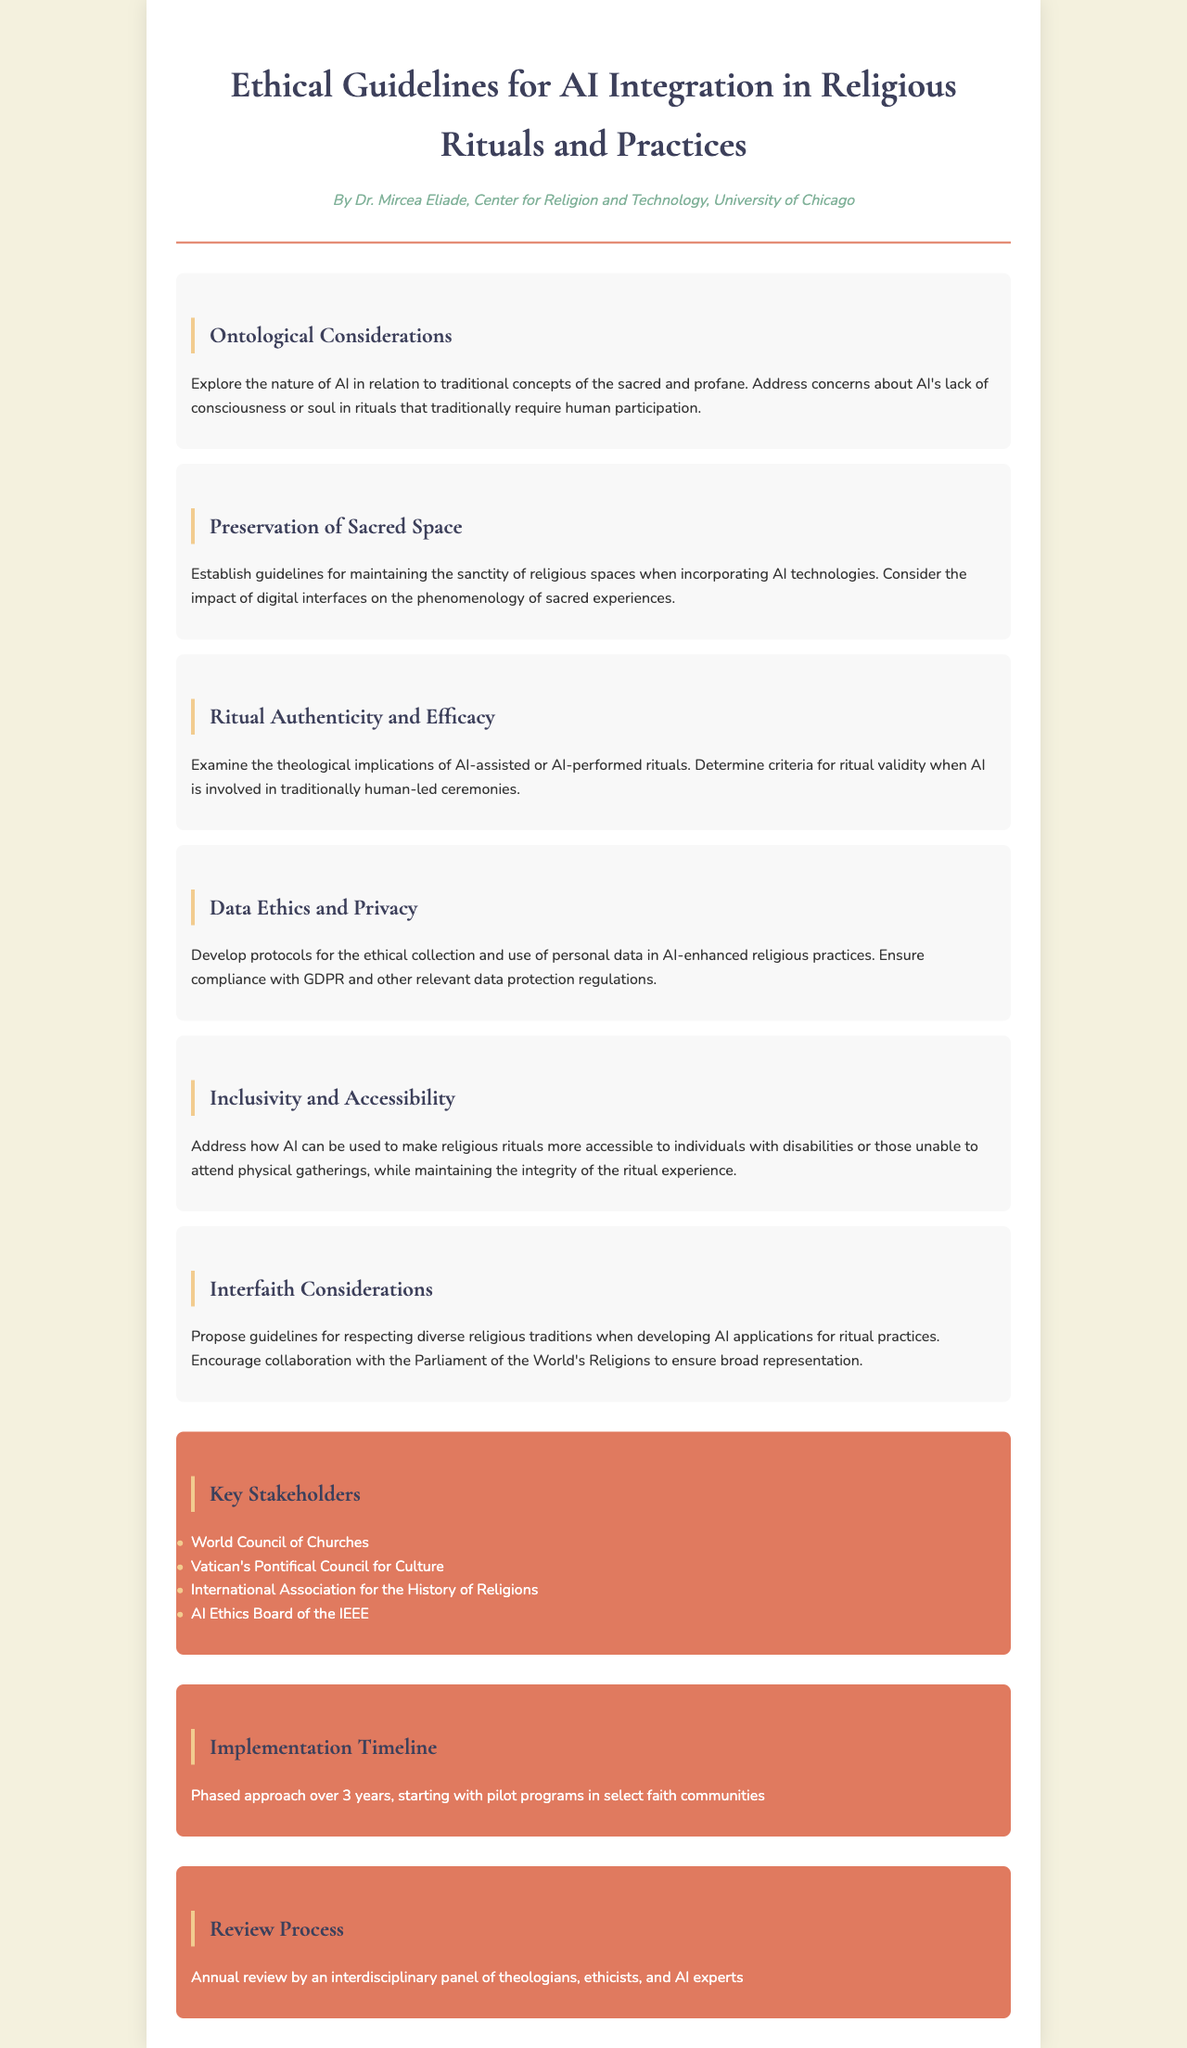What is the title of the document? The title of the document is found in the header section.
Answer: Ethical Guidelines for AI Integration in Religious Rituals and Practices Who authored the document? The author's name is listed below the title in the header section.
Answer: Dr. Mircea Eliade What is one of the ethical considerations mentioned in the document? Ethical considerations are addressed in various sections of the document.
Answer: Data Ethics and Privacy How many key stakeholders are listed in the document? The number of stakeholders can be counted in the "Key Stakeholders" section.
Answer: Four What is the proposed duration for the implementation timeline? The duration is specified in the "Implementation Timeline" section.
Answer: Three years What is one of the purposes of AI in religious rituals according to the document? The document discusses various purposes in the "Inclusivity and Accessibility" section.
Answer: Make religious rituals more accessible Which organization is mentioned as a stakeholder in the document? Stakeholders can be found in the "Key Stakeholders" section.
Answer: World Council of Churches What is the review process mentioned in the document? The review process is described in the "Review Process" section.
Answer: Annual review by an interdisciplinary panel What topic is explored in the "Ontological Considerations" section? The topic is introduced in the section title and elaborated in the text.
Answer: Nature of AI in relation to traditional concepts of the sacred 